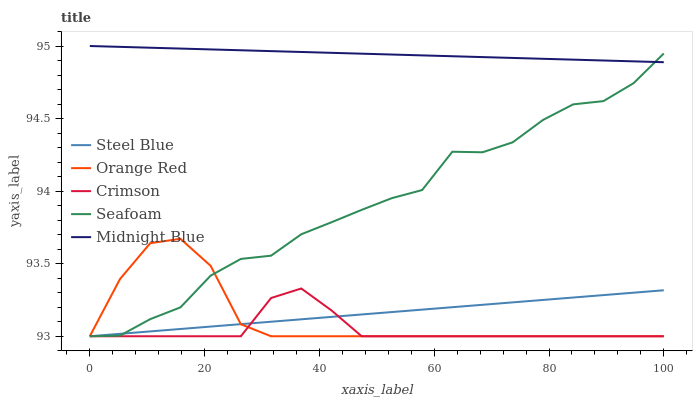Does Crimson have the minimum area under the curve?
Answer yes or no. Yes. Does Midnight Blue have the maximum area under the curve?
Answer yes or no. Yes. Does Seafoam have the minimum area under the curve?
Answer yes or no. No. Does Seafoam have the maximum area under the curve?
Answer yes or no. No. Is Steel Blue the smoothest?
Answer yes or no. Yes. Is Seafoam the roughest?
Answer yes or no. Yes. Is Midnight Blue the smoothest?
Answer yes or no. No. Is Midnight Blue the roughest?
Answer yes or no. No. Does Crimson have the lowest value?
Answer yes or no. Yes. Does Midnight Blue have the lowest value?
Answer yes or no. No. Does Midnight Blue have the highest value?
Answer yes or no. Yes. Does Seafoam have the highest value?
Answer yes or no. No. Is Crimson less than Midnight Blue?
Answer yes or no. Yes. Is Midnight Blue greater than Crimson?
Answer yes or no. Yes. Does Steel Blue intersect Crimson?
Answer yes or no. Yes. Is Steel Blue less than Crimson?
Answer yes or no. No. Is Steel Blue greater than Crimson?
Answer yes or no. No. Does Crimson intersect Midnight Blue?
Answer yes or no. No. 